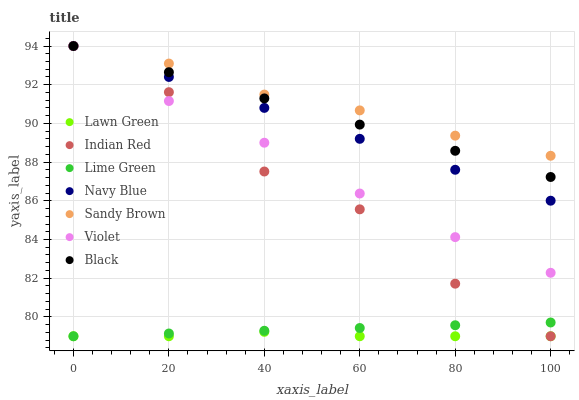Does Lawn Green have the minimum area under the curve?
Answer yes or no. Yes. Does Sandy Brown have the maximum area under the curve?
Answer yes or no. Yes. Does Navy Blue have the minimum area under the curve?
Answer yes or no. No. Does Navy Blue have the maximum area under the curve?
Answer yes or no. No. Is Black the smoothest?
Answer yes or no. Yes. Is Indian Red the roughest?
Answer yes or no. Yes. Is Sandy Brown the smoothest?
Answer yes or no. No. Is Sandy Brown the roughest?
Answer yes or no. No. Does Lawn Green have the lowest value?
Answer yes or no. Yes. Does Navy Blue have the lowest value?
Answer yes or no. No. Does Violet have the highest value?
Answer yes or no. Yes. Does Lime Green have the highest value?
Answer yes or no. No. Is Lime Green less than Black?
Answer yes or no. Yes. Is Sandy Brown greater than Lawn Green?
Answer yes or no. Yes. Does Indian Red intersect Navy Blue?
Answer yes or no. Yes. Is Indian Red less than Navy Blue?
Answer yes or no. No. Is Indian Red greater than Navy Blue?
Answer yes or no. No. Does Lime Green intersect Black?
Answer yes or no. No. 